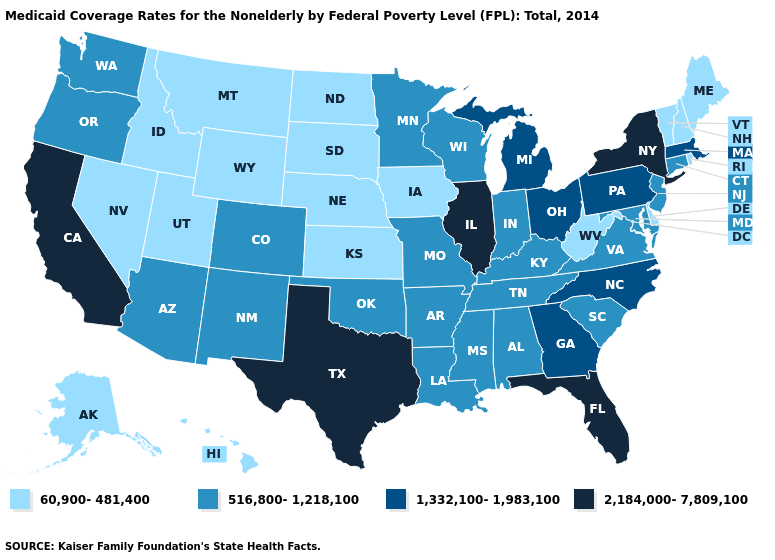What is the value of Georgia?
Short answer required. 1,332,100-1,983,100. What is the value of Wisconsin?
Keep it brief. 516,800-1,218,100. What is the highest value in states that border Tennessee?
Keep it brief. 1,332,100-1,983,100. What is the value of Kansas?
Quick response, please. 60,900-481,400. Does South Dakota have the highest value in the USA?
Be succinct. No. What is the highest value in the USA?
Concise answer only. 2,184,000-7,809,100. What is the highest value in states that border Mississippi?
Short answer required. 516,800-1,218,100. Which states hav the highest value in the Northeast?
Quick response, please. New York. What is the highest value in states that border Minnesota?
Quick response, please. 516,800-1,218,100. Name the states that have a value in the range 2,184,000-7,809,100?
Write a very short answer. California, Florida, Illinois, New York, Texas. Is the legend a continuous bar?
Be succinct. No. Which states have the lowest value in the USA?
Answer briefly. Alaska, Delaware, Hawaii, Idaho, Iowa, Kansas, Maine, Montana, Nebraska, Nevada, New Hampshire, North Dakota, Rhode Island, South Dakota, Utah, Vermont, West Virginia, Wyoming. Name the states that have a value in the range 2,184,000-7,809,100?
Concise answer only. California, Florida, Illinois, New York, Texas. Among the states that border Arizona , which have the highest value?
Give a very brief answer. California. What is the lowest value in the USA?
Concise answer only. 60,900-481,400. 